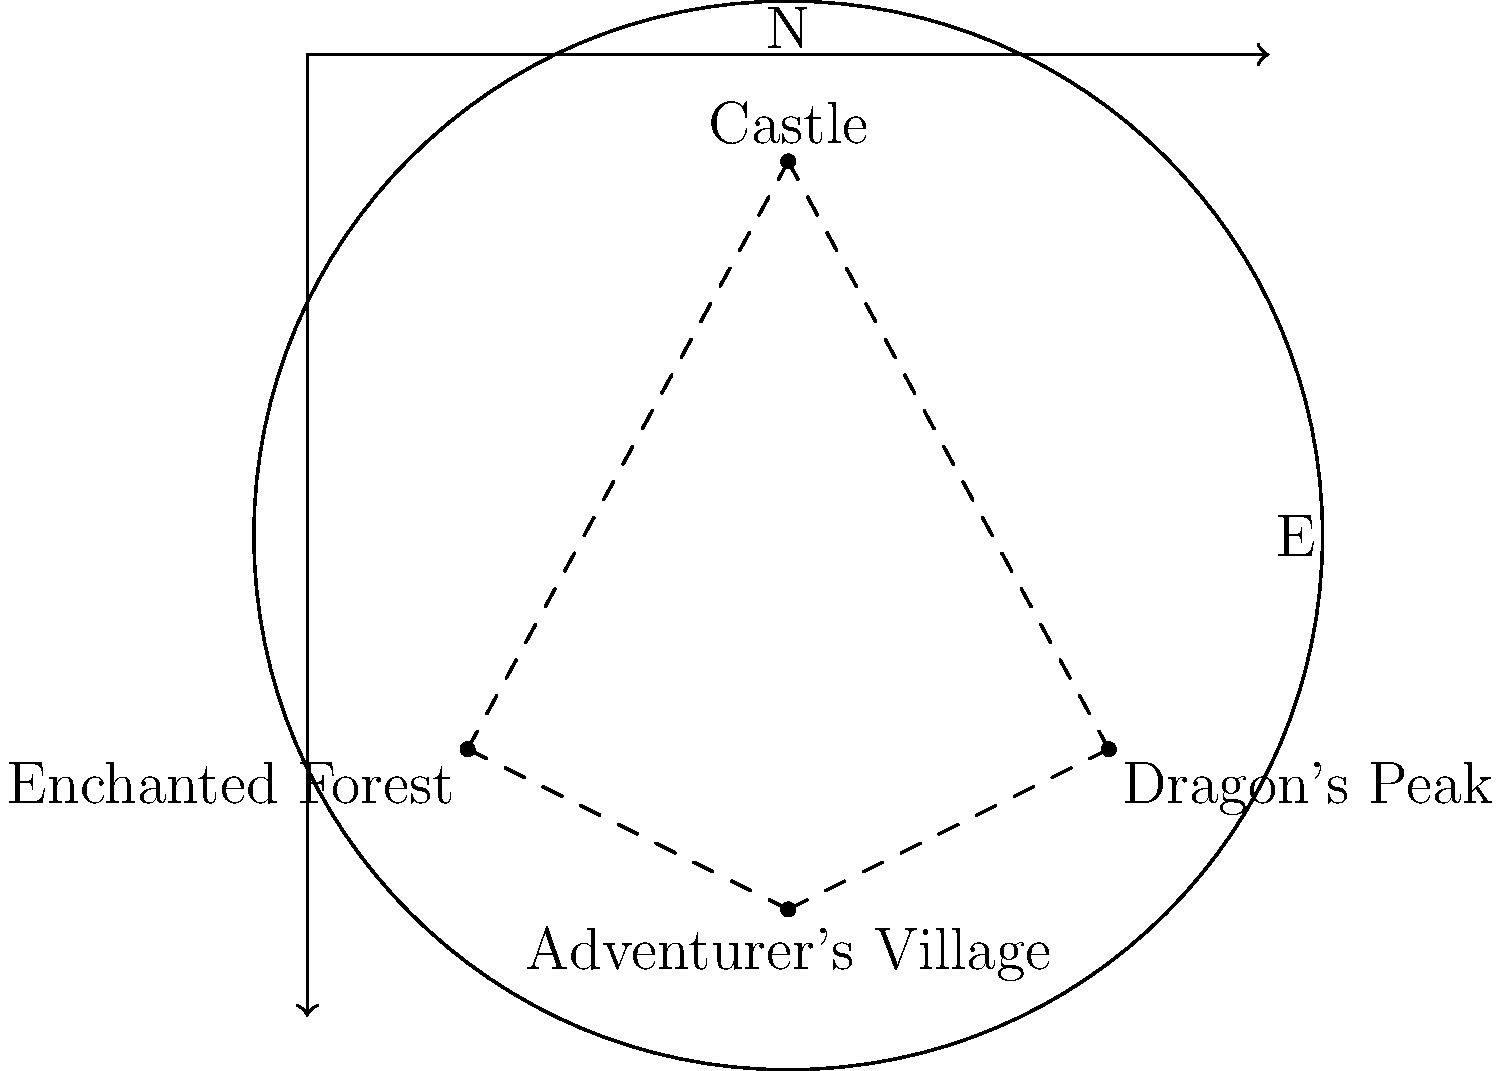Based on the fantasy RPG map, which location would be the most efficient starting point for a quest that requires visiting all landmarks in the shortest possible route? To determine the most efficient starting point, we need to analyze the map and consider the distances between locations:

1. The map shows four key locations: Castle, Enchanted Forest, Dragon's Peak, and Adventurer's Village.
2. These locations form a roughly diamond-shaped path on the map.
3. To visit all landmarks in the shortest route, we need to minimize backtracking.
4. Starting from any corner of the diamond would allow us to move in a single direction (clockwise or counterclockwise) to visit all locations.
5. However, the Adventurer's Village is positioned at the bottom of the map, making it a central point.
6. Starting from the Adventurer's Village allows for:
   a) Easy access to both the Enchanted Forest and Dragon's Peak
   b) A final leg of the journey ending at the Castle, which is often the culmination point in RPGs

Therefore, the Adventurer's Village provides the most efficient starting point for visiting all landmarks in the shortest possible route.
Answer: Adventurer's Village 